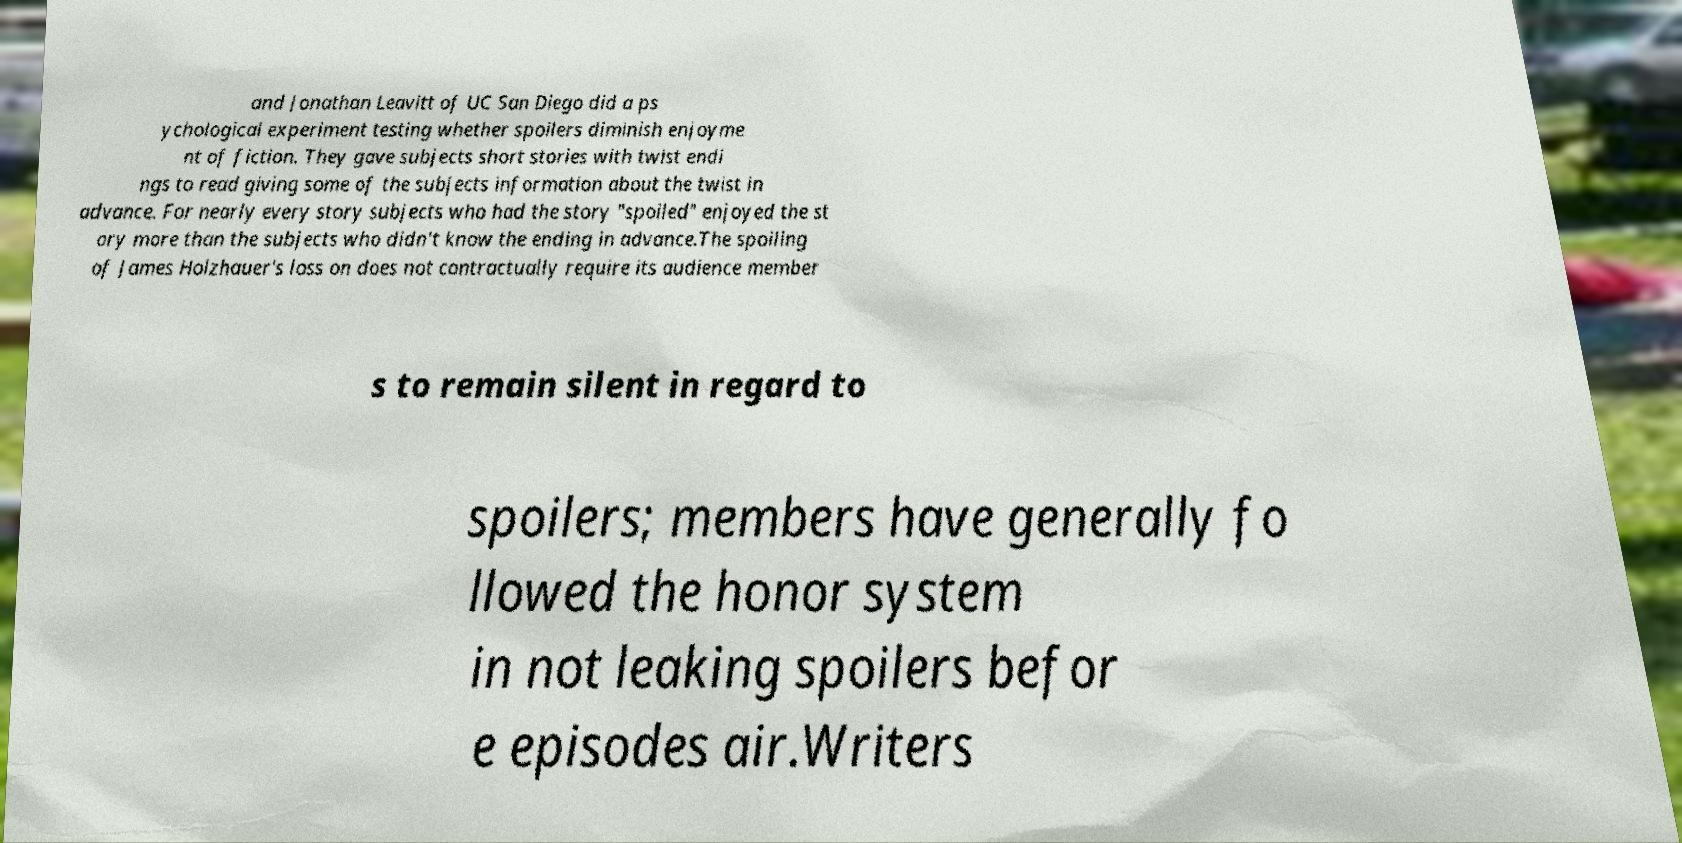Can you read and provide the text displayed in the image?This photo seems to have some interesting text. Can you extract and type it out for me? and Jonathan Leavitt of UC San Diego did a ps ychological experiment testing whether spoilers diminish enjoyme nt of fiction. They gave subjects short stories with twist endi ngs to read giving some of the subjects information about the twist in advance. For nearly every story subjects who had the story "spoiled" enjoyed the st ory more than the subjects who didn't know the ending in advance.The spoiling of James Holzhauer's loss on does not contractually require its audience member s to remain silent in regard to spoilers; members have generally fo llowed the honor system in not leaking spoilers befor e episodes air.Writers 